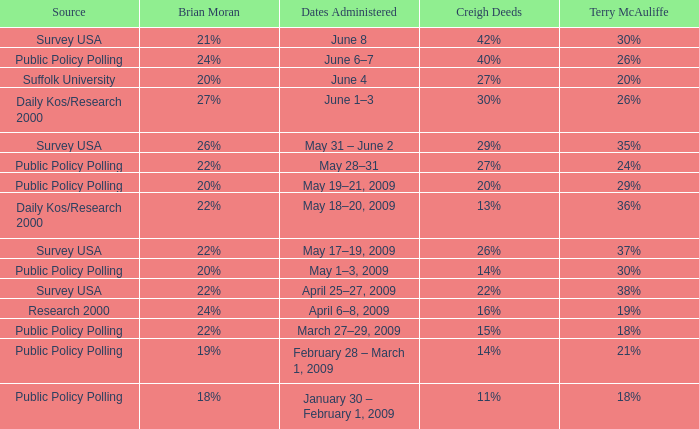Which Source has Terry McAuliffe of 36% Daily Kos/Research 2000. 